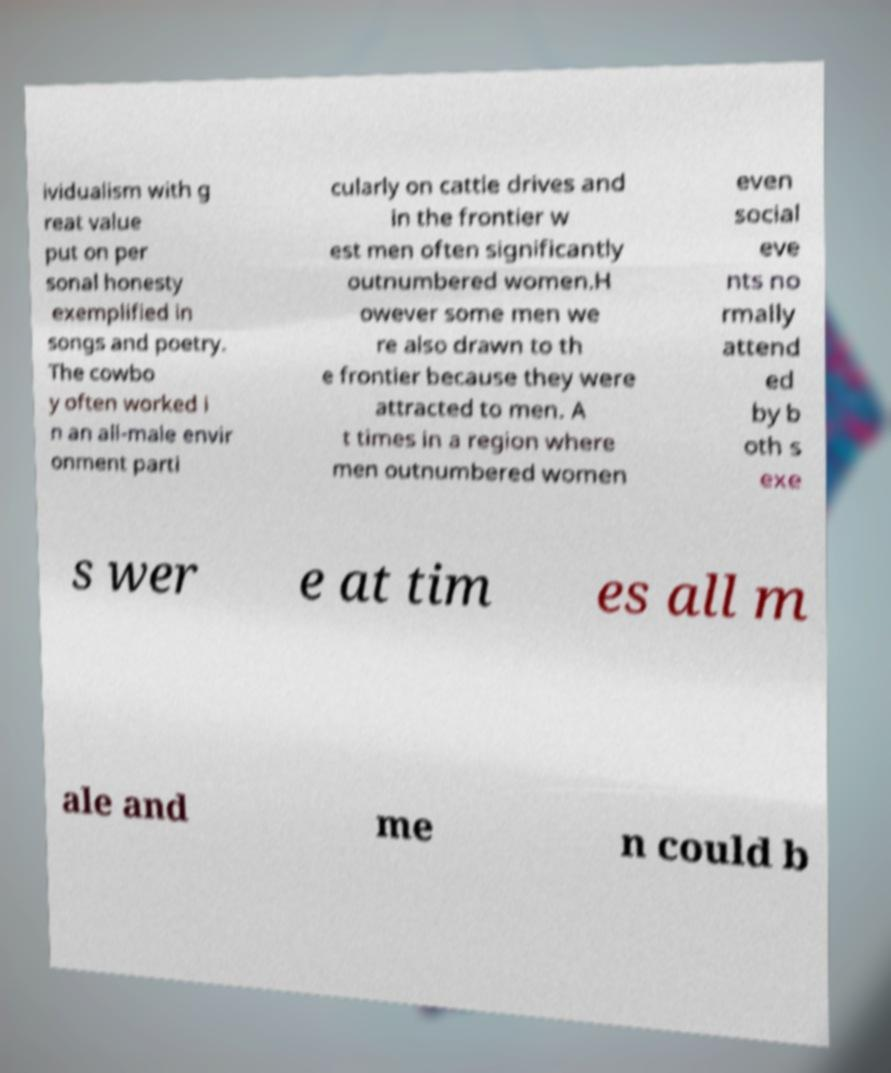What messages or text are displayed in this image? I need them in a readable, typed format. ividualism with g reat value put on per sonal honesty exemplified in songs and poetry. The cowbo y often worked i n an all-male envir onment parti cularly on cattle drives and in the frontier w est men often significantly outnumbered women.H owever some men we re also drawn to th e frontier because they were attracted to men. A t times in a region where men outnumbered women even social eve nts no rmally attend ed by b oth s exe s wer e at tim es all m ale and me n could b 